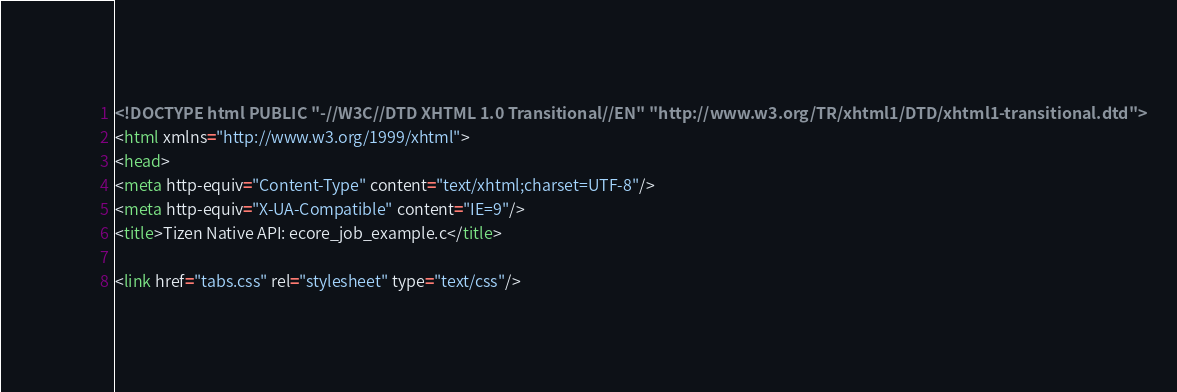Convert code to text. <code><loc_0><loc_0><loc_500><loc_500><_HTML_><!DOCTYPE html PUBLIC "-//W3C//DTD XHTML 1.0 Transitional//EN" "http://www.w3.org/TR/xhtml1/DTD/xhtml1-transitional.dtd">
<html xmlns="http://www.w3.org/1999/xhtml">
<head>
<meta http-equiv="Content-Type" content="text/xhtml;charset=UTF-8"/>
<meta http-equiv="X-UA-Compatible" content="IE=9"/>
<title>Tizen Native API: ecore_job_example.c</title>

<link href="tabs.css" rel="stylesheet" type="text/css"/></code> 